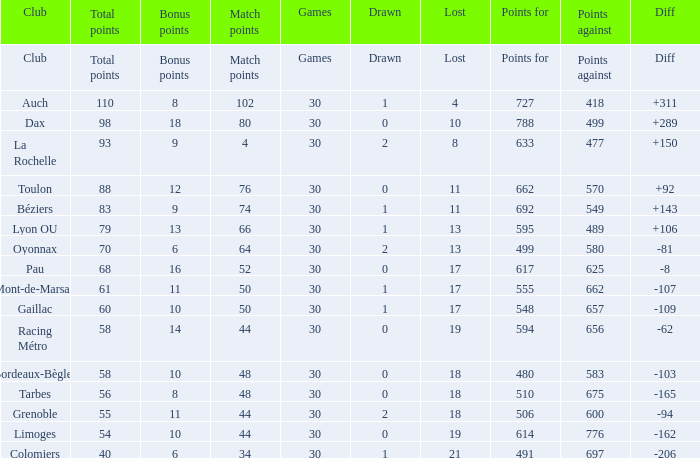What is the value of match points when the points for is 570? 76.0. 